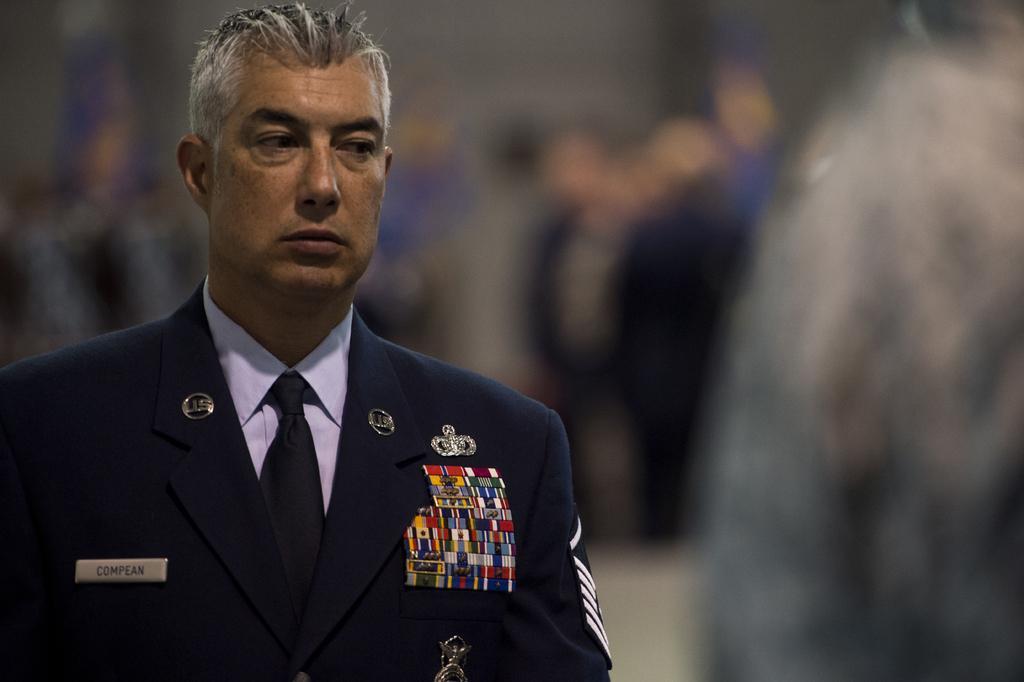Please provide a concise description of this image. In this image we can see a person in a costume and we can also see a blurred background. 